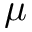<formula> <loc_0><loc_0><loc_500><loc_500>\mu</formula> 